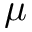<formula> <loc_0><loc_0><loc_500><loc_500>\mu</formula> 